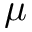<formula> <loc_0><loc_0><loc_500><loc_500>\mu</formula> 